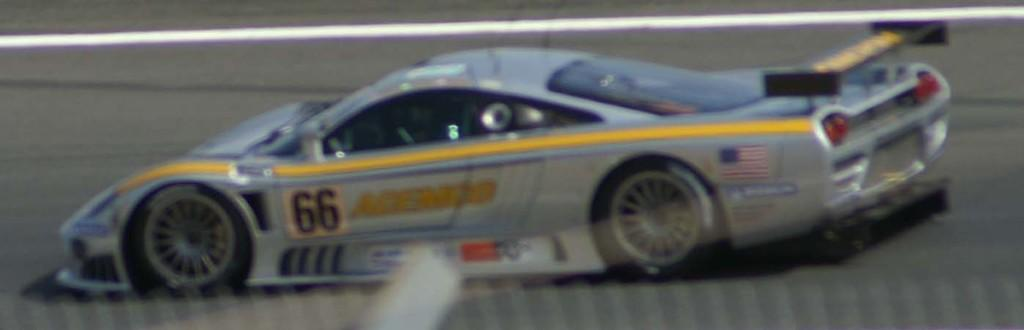What is the main subject of the picture? The main subject of the picture is a blurred image of a racing car. Where is the racing car located? The racing car is on the road. What can be seen on the road besides the racing car? There is a white line on the road. How does the racing car contribute to the health of the driver in the image? The image does not provide any information about the health of the driver or the racing car's contribution to it. --- 